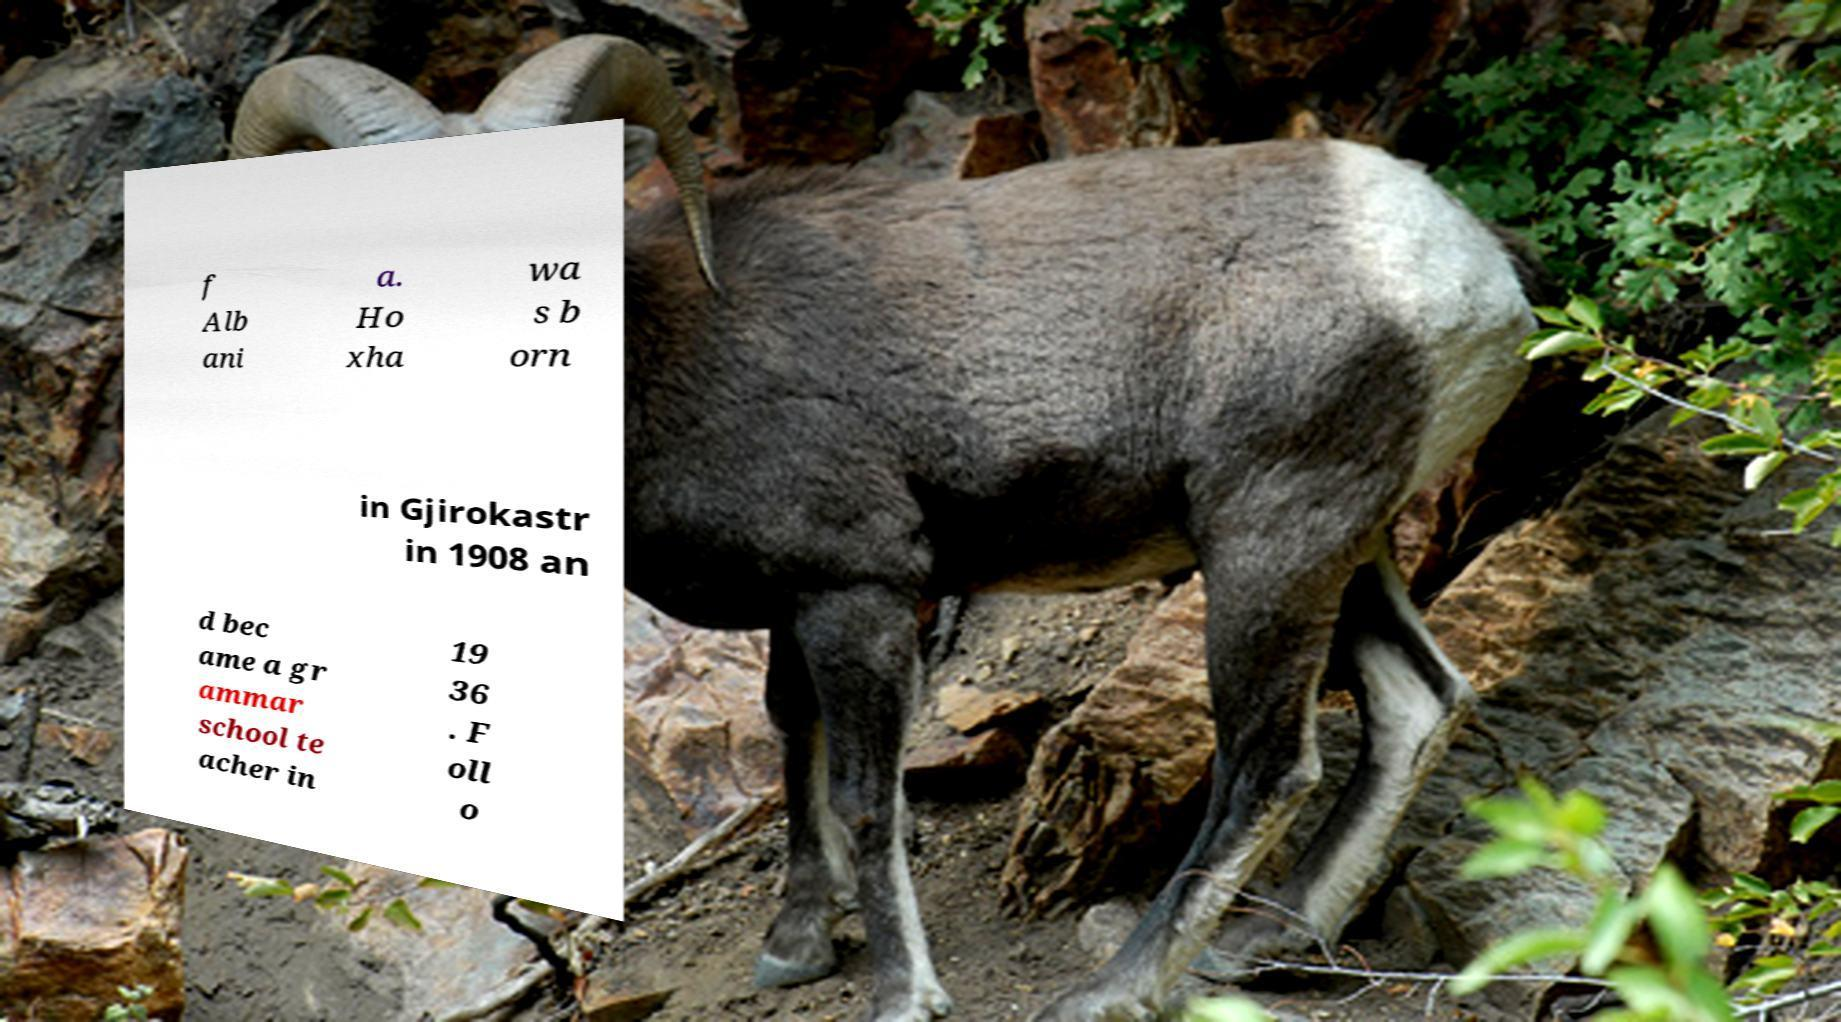Could you assist in decoding the text presented in this image and type it out clearly? f Alb ani a. Ho xha wa s b orn in Gjirokastr in 1908 an d bec ame a gr ammar school te acher in 19 36 . F oll o 